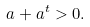<formula> <loc_0><loc_0><loc_500><loc_500>a + a ^ { t } > 0 .</formula> 